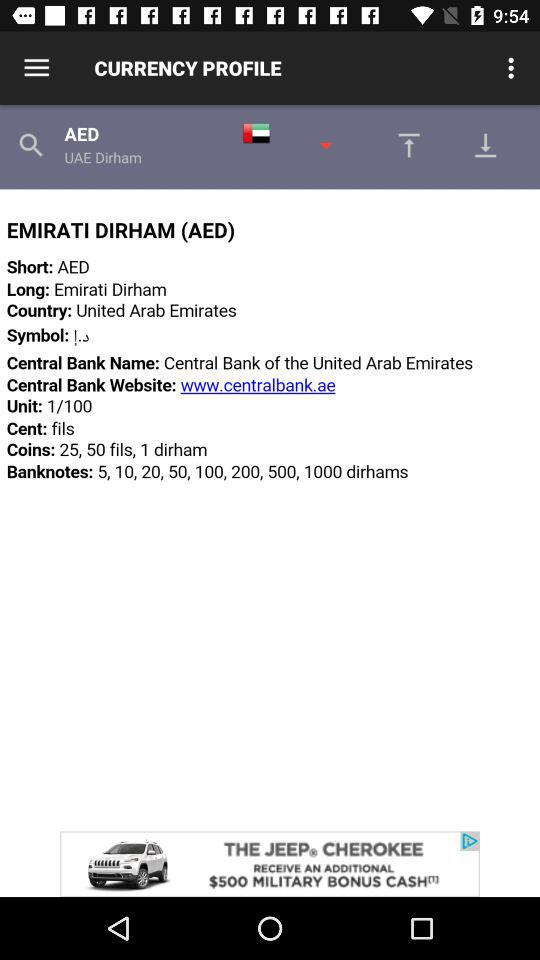Which tab has been selected?
When the provided information is insufficient, respond with <no answer>. <no answer> 